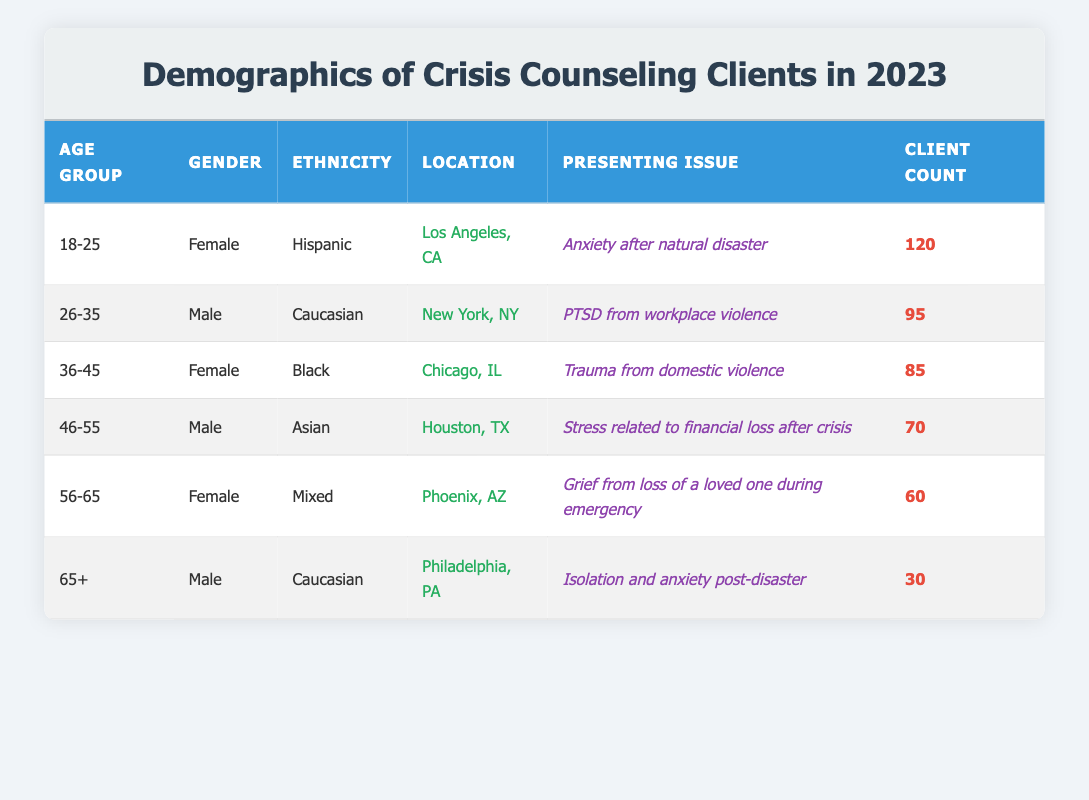What is the client count for the age group 18-25? The table lists the client count for the age group 18-25 as 120.
Answer: 120 Which location has the highest client count? By examining the client counts for each location, Los Angeles, CA has the highest at 120, followed by New York, NY with 95.
Answer: Los Angeles, CA What percentage of clients are male? There are 3 male clients (26-35, 46-55, and 65+ age groups) and 3 female clients (18-25, 36-45, and 56-65 age groups) out of a total of 6 clients. Therefore, the percentage of male clients is (3/6) * 100 = 50%.
Answer: 50% Is there a client from Houston, TX? Yes, the table indicates that there is one client from Houston, TX who is in the 46-55 age group.
Answer: Yes What is the total client count for the age group 36-45 and 46-55? For the age group 36-45, the client count is 85, and for the age group 46-55, the client count is 70. Summing these gives 85 + 70 = 155.
Answer: 155 How many presenting issues are listed for clients in the age group 56-65? The table indicates that there is one presenting issue listed for the 56-65 age group: grief from the loss of a loved one during an emergency.
Answer: 1 What is the average client count across all age groups? To calculate the average, sum the client counts: 120 + 95 + 85 + 70 + 60 + 30 = 460. There are 6 age groups, so the average is 460/6 = approximately 76.67.
Answer: 76.67 Are there any clients in the location of Philadelphia, PA? Yes, the table shows there is one client from Philadelphia, PA in the age group 65+.
Answer: Yes What is the difference in client count between the age groups 26-35 and 56-65? The client count for age group 26-35 is 95 and for 56-65 is 60. The difference is 95 - 60 = 35.
Answer: 35 